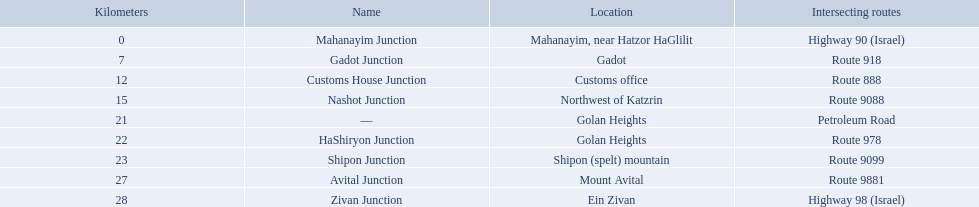Which junctions are located on numbered routes, and not highways or other types? Gadot Junction, Customs House Junction, Nashot Junction, HaShiryon Junction, Shipon Junction, Avital Junction. Of these junctions, which ones are located on routes with four digits (ex. route 9999)? Nashot Junction, Shipon Junction, Avital Junction. Of the remaining routes, which is located on shipon (spelt) mountain? Shipon Junction. How many kilometers away is shipon junction? 23. How many kilometers away is avital junction? 27. Which one is closer to nashot junction? Shipon Junction. Which crossroads are located on numbered routes, excluding highways or other types? Gadot Junction, Customs House Junction, Nashot Junction, HaShiryon Junction, Shipon Junction, Avital Junction. From these crossroads, which ones are placed on routes with four figures (such as route 9999)? Nashot Junction, Shipon Junction, Avital Junction. Of the rest of the routes, which is positioned on shipon (spelt) mountain? Shipon Junction. Which crossings overlap a route? Gadot Junction, Customs House Junction, Nashot Junction, HaShiryon Junction, Shipon Junction, Avital Junction. Which of these contains a fragment of its name that corresponds with its location's name? Gadot Junction, Customs House Junction, Shipon Junction, Avital Junction. Which of them is not positioned in a locale named after a mountain? Gadot Junction, Customs House Junction. Which of these carries the largest route number? Gadot Junction. Which intersections are situated on numbered routes, and not freeways or other kinds? Gadot Junction, Customs House Junction, Nashot Junction, HaShiryon Junction, Shipon Junction, Avital Junction. Among these intersections, which ones are found on routes with four numerals (e.g. route 9999)? Nashot Junction, Shipon Junction, Avital Junction. Of the leftover routes, which is positioned on shipon (spelt) mountain? Shipon Junction. Which intersections exist on numbered routes, rather than highways or different types? Gadot Junction, Customs House Junction, Nashot Junction, HaShiryon Junction, Shipon Junction, Avital Junction. Of these intersections, which are located on four-digit routes (such as route 9999)? Nashot Junction, Shipon Junction, Avital Junction. Among the remaining routes, which one can be found on shipon mountain? Shipon Junction. What's the distance in kilometers from shipon junction? 23. What's the distance in kilometers from avital junction? 27. Which junction, either shipon or avital, has a shorter distance to nashot junction? Shipon Junction. Which intersections intersect a specific route? Gadot Junction, Customs House Junction, Nashot Junction, HaShiryon Junction, Shipon Junction, Avital Junction. Among these, which one has a portion of its name similar to the location's name? Gadot Junction, Customs House Junction, Shipon Junction, Avital Junction. Parse the full table in json format. {'header': ['Kilometers', 'Name', 'Location', 'Intersecting routes'], 'rows': [['0', 'Mahanayim Junction', 'Mahanayim, near Hatzor HaGlilit', 'Highway 90 (Israel)'], ['7', 'Gadot Junction', 'Gadot', 'Route 918'], ['12', 'Customs House Junction', 'Customs office', 'Route 888'], ['15', 'Nashot Junction', 'Northwest of Katzrin', 'Route 9088'], ['21', '—', 'Golan Heights', 'Petroleum Road'], ['22', 'HaShiryon Junction', 'Golan Heights', 'Route 978'], ['23', 'Shipon Junction', 'Shipon (spelt) mountain', 'Route 9099'], ['27', 'Avital Junction', 'Mount Avital', 'Route 9881'], ['28', 'Zivan Junction', 'Ein Zivan', 'Highway 98 (Israel)']]} Which one is not situated in an area named after a mountain? Gadot Junction, Customs House Junction. Lastly, which one has the highest route number? Gadot Junction. What intersections can be found along a particular route? Gadot Junction, Customs House Junction, Nashot Junction, HaShiryon Junction, Shipon Junction, Avital Junction. From these, which shares part of its name with the name of its location? Gadot Junction, Customs House Junction, Shipon Junction, Avital Junction. Which is not located in a place named after a mountain? Gadot Junction, Customs House Junction. Moreover, which junction has the highest route number? Gadot Junction. 